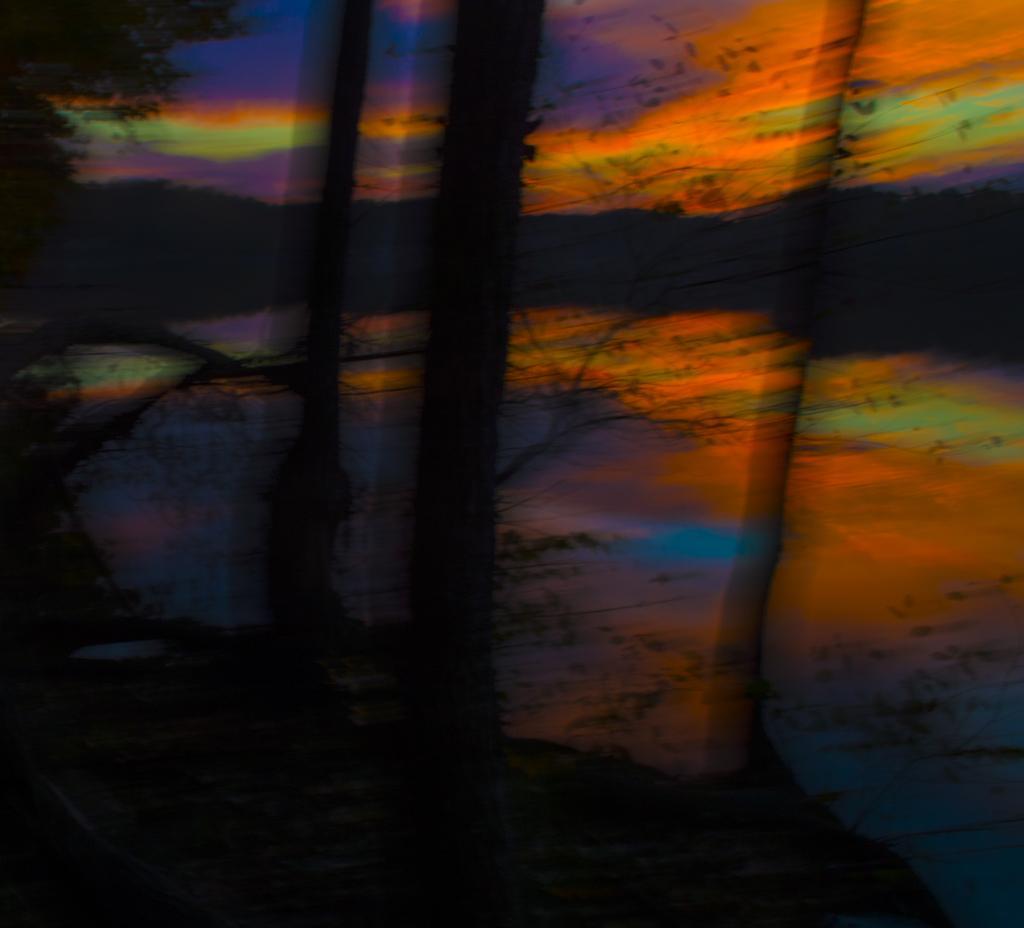Please provide a concise description of this image. In this image we can see ground, trees and sky in the background. 